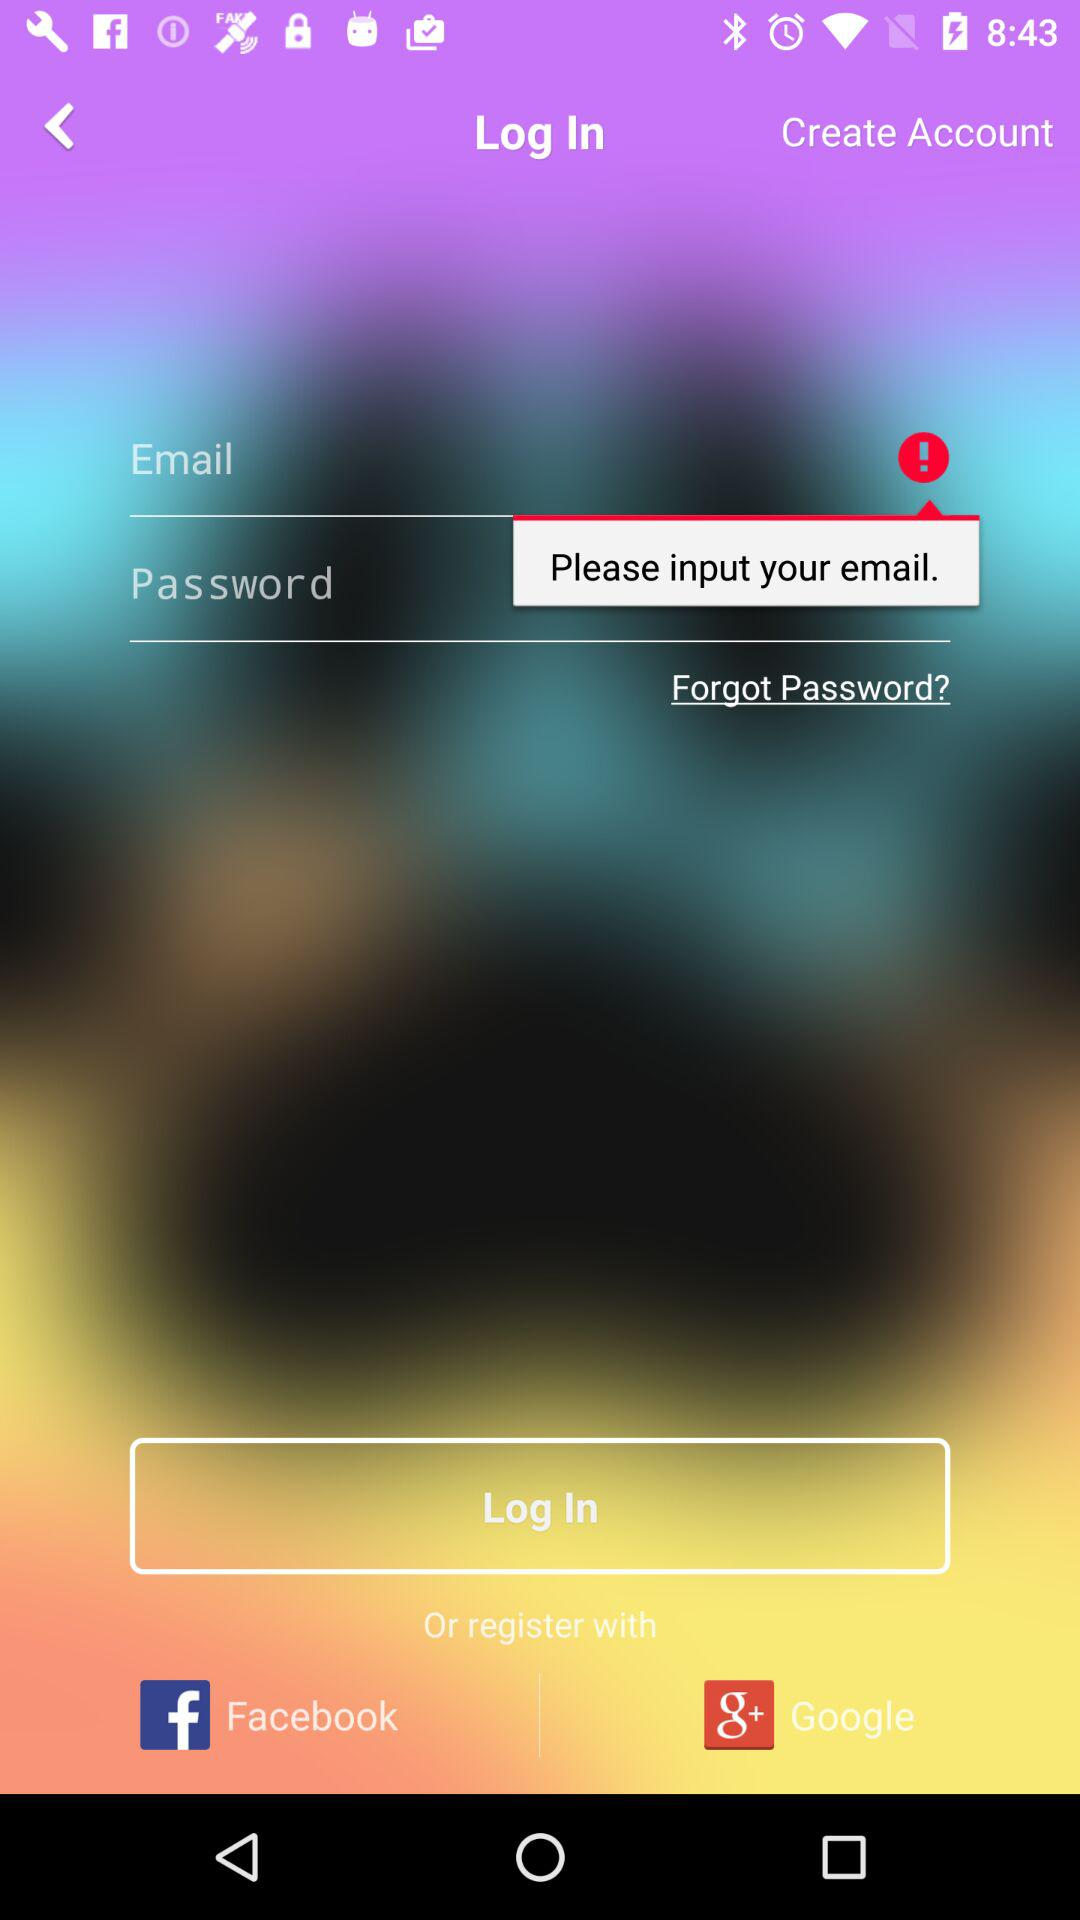How many text inputs are required to log in?
Answer the question using a single word or phrase. 2 